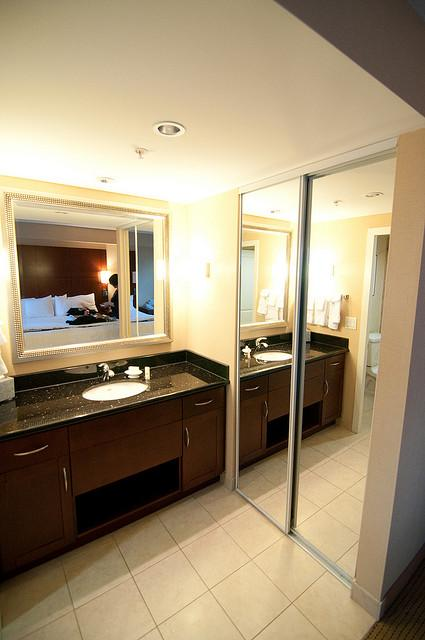What is behind the two tall mirrors? closet 